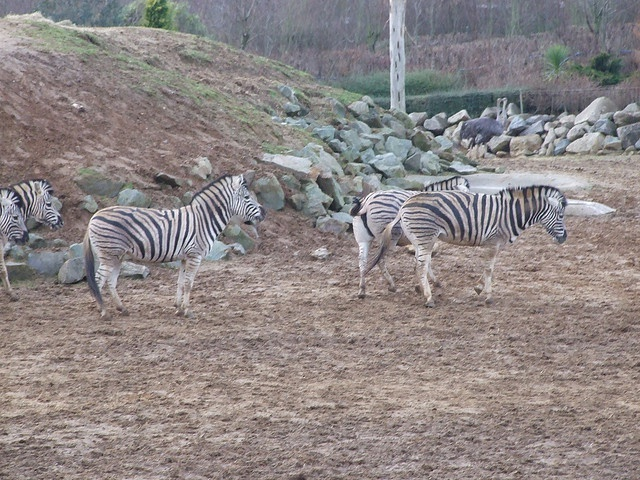Describe the objects in this image and their specific colors. I can see zebra in gray, darkgray, and lightgray tones, zebra in gray, darkgray, and lightgray tones, zebra in gray, darkgray, and lightgray tones, zebra in gray, darkgray, lightgray, and black tones, and zebra in gray, darkgray, lightgray, and black tones in this image. 